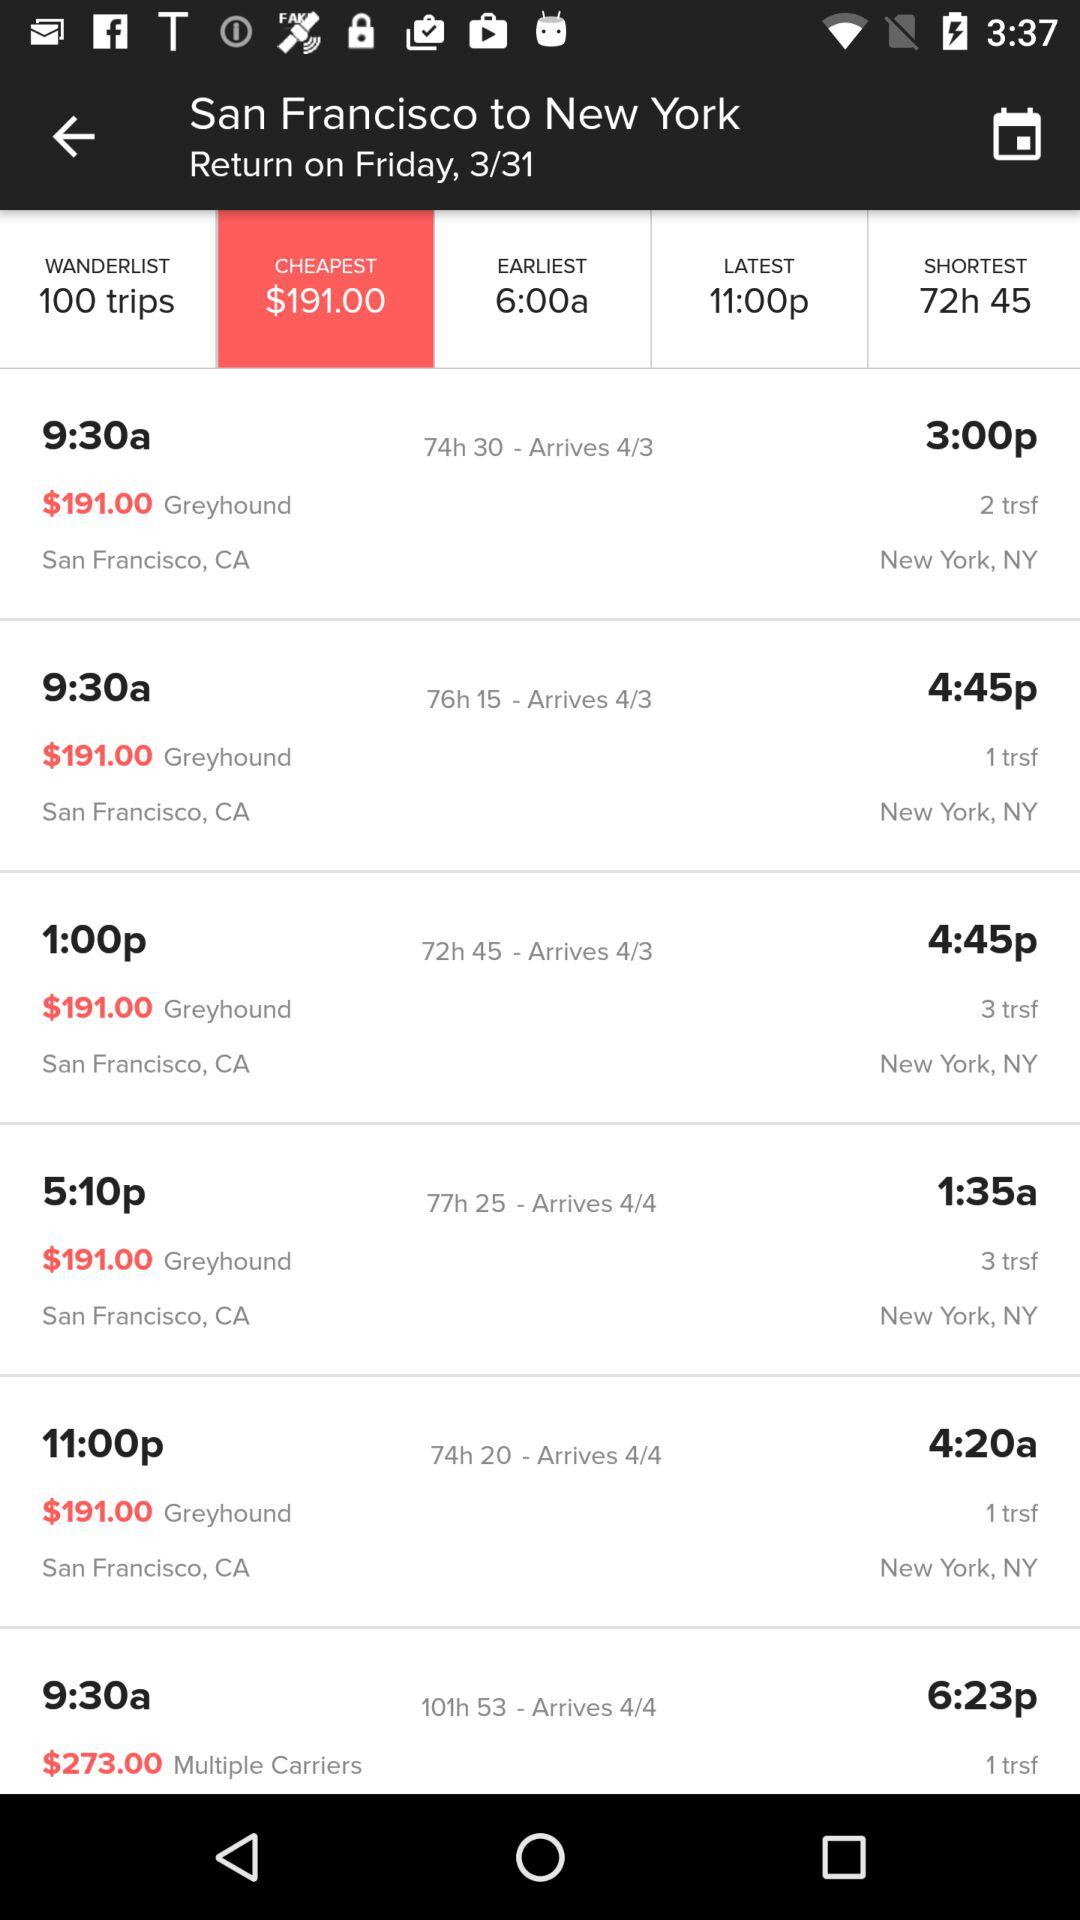What is the name of the city from where I am travelling? The name of the city from where you are travelling is San Francisco. 